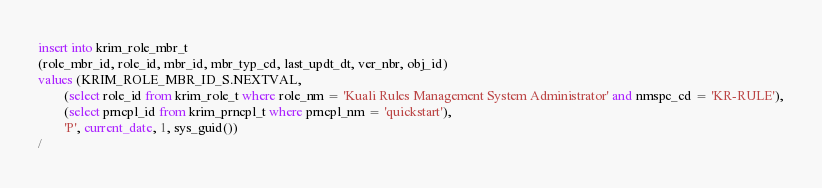<code> <loc_0><loc_0><loc_500><loc_500><_SQL_>insert into krim_role_mbr_t
(role_mbr_id, role_id, mbr_id, mbr_typ_cd, last_updt_dt, ver_nbr, obj_id)
values (KRIM_ROLE_MBR_ID_S.NEXTVAL,
		(select role_id from krim_role_t where role_nm = 'Kuali Rules Management System Administrator' and nmspc_cd = 'KR-RULE'),
        (select prncpl_id from krim_prncpl_t where prncpl_nm = 'quickstart'),
        'P', current_date, 1, sys_guid())
/
</code> 